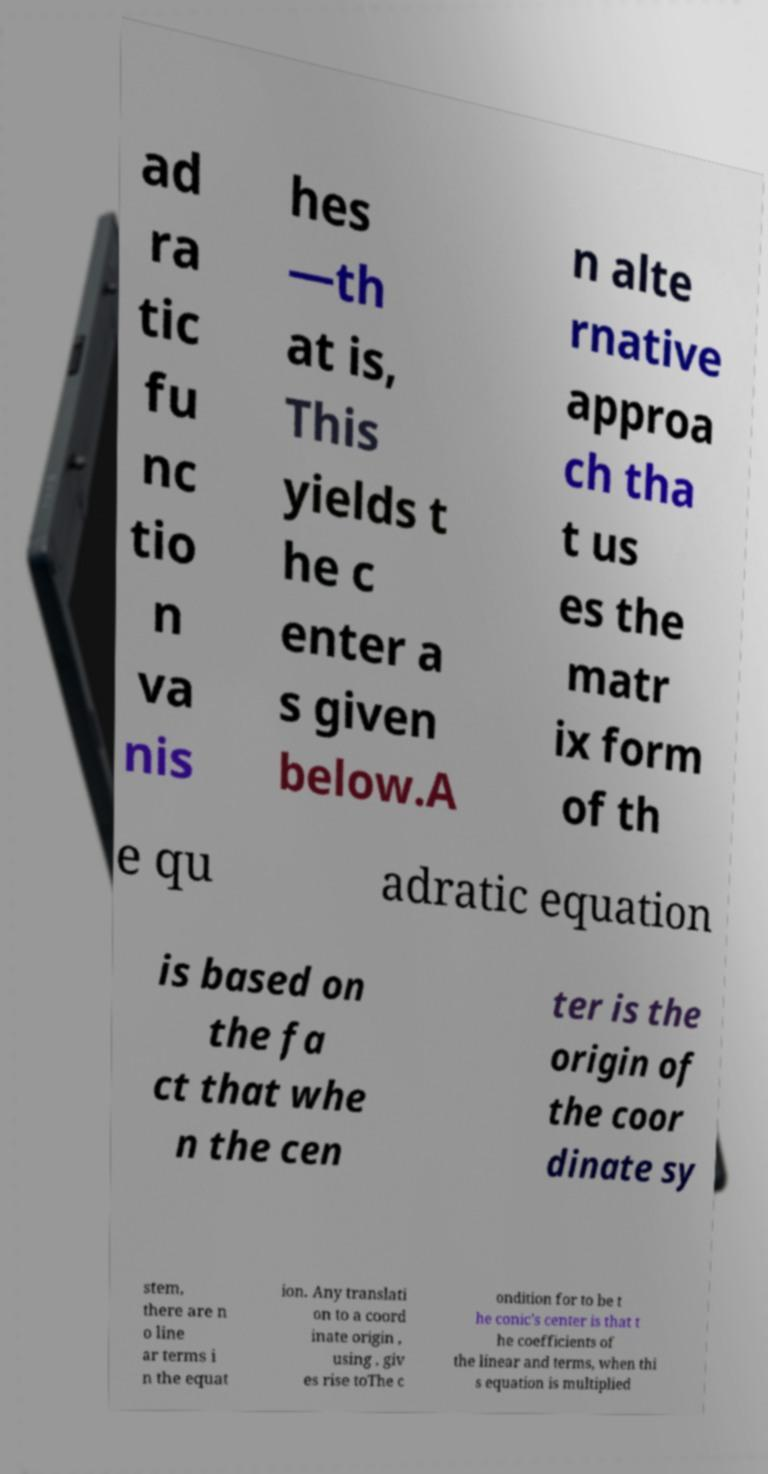What messages or text are displayed in this image? I need them in a readable, typed format. ad ra tic fu nc tio n va nis hes —th at is, This yields t he c enter a s given below.A n alte rnative approa ch tha t us es the matr ix form of th e qu adratic equation is based on the fa ct that whe n the cen ter is the origin of the coor dinate sy stem, there are n o line ar terms i n the equat ion. Any translati on to a coord inate origin , using , giv es rise toThe c ondition for to be t he conic's center is that t he coefficients of the linear and terms, when thi s equation is multiplied 